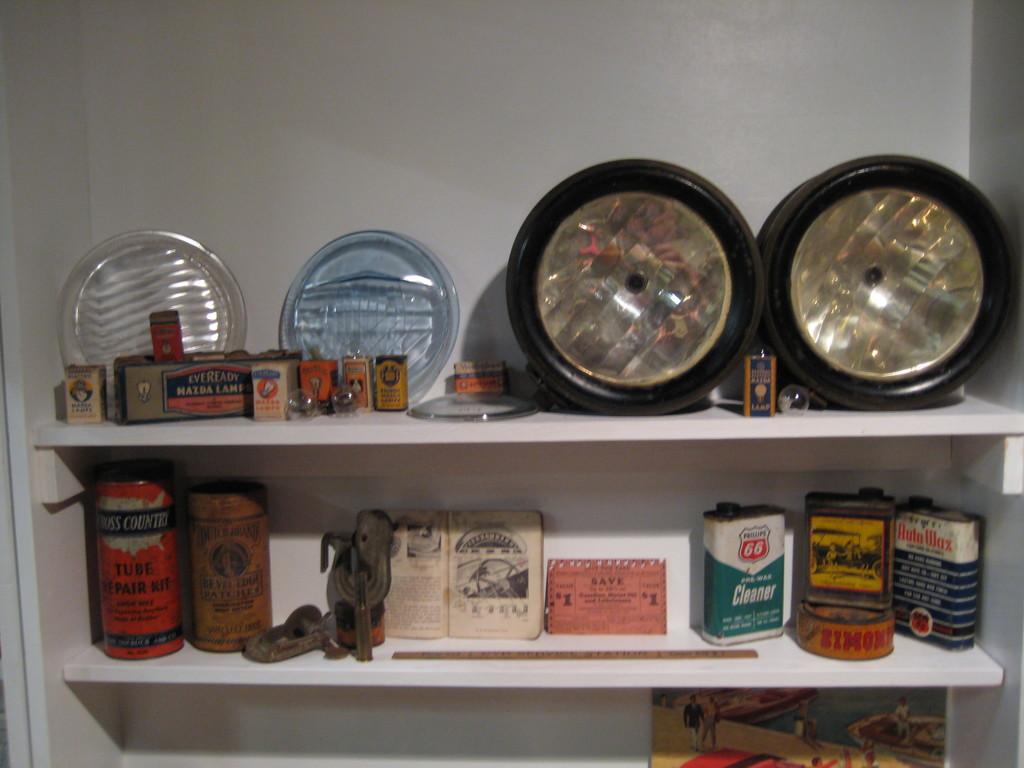What is in the orange can?
Make the answer very short. Tube repair kit. What is in the green and white can?
Give a very brief answer. Cleaner. 